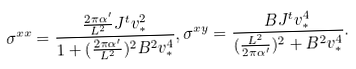<formula> <loc_0><loc_0><loc_500><loc_500>\sigma ^ { x x } = \frac { \frac { 2 \pi \alpha ^ { \prime } } { L ^ { 2 } } J ^ { t } v _ { \ast } ^ { 2 } } { 1 + ( \frac { 2 \pi \alpha ^ { \prime } } { L ^ { 2 } } ) ^ { 2 } B ^ { 2 } v _ { \ast } ^ { 4 } } , \sigma ^ { x y } = \frac { B J ^ { t } v _ { \ast } ^ { 4 } } { ( \frac { L ^ { 2 } } { 2 \pi \alpha ^ { \prime } } ) ^ { 2 } + B ^ { 2 } v _ { \ast } ^ { 4 } } .</formula> 